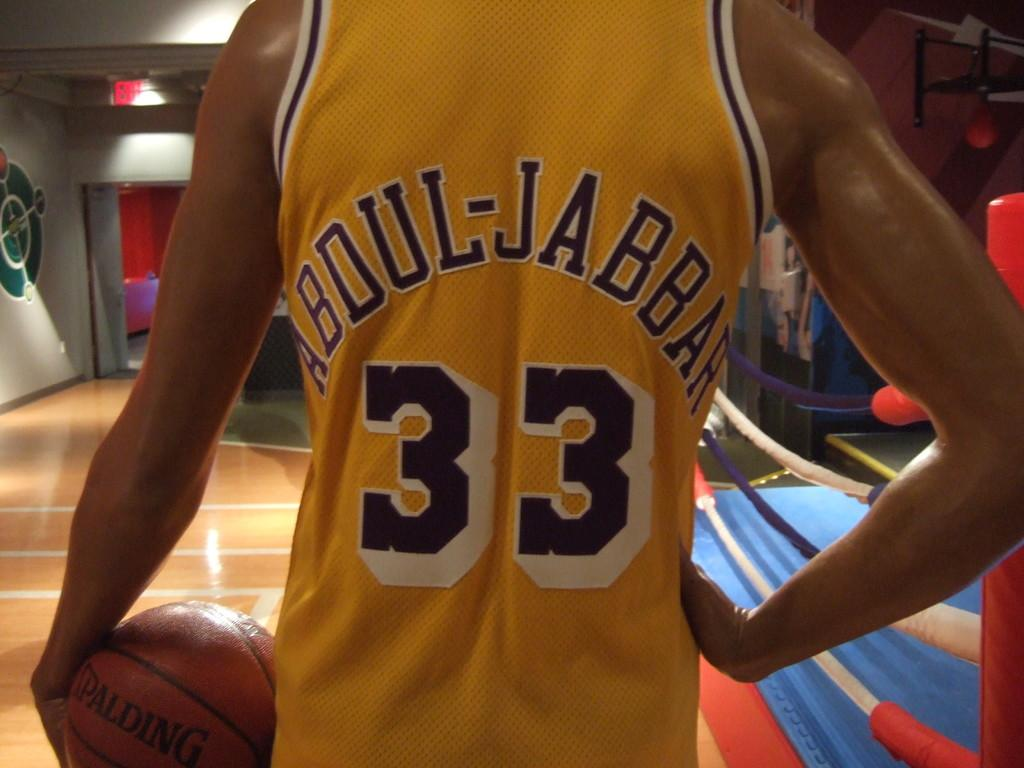<image>
Write a terse but informative summary of the picture. Man wearing a basketball jersey of the number 33. 